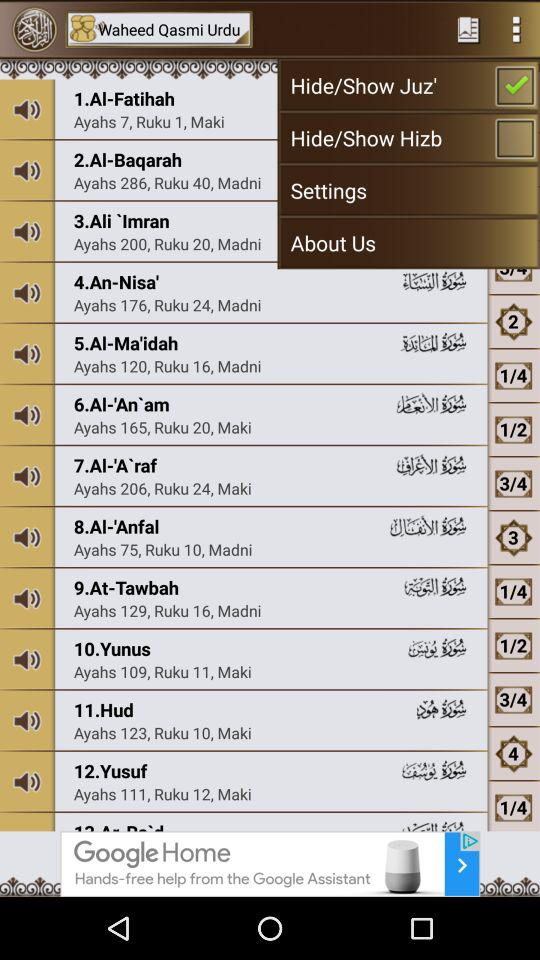How many rukus are there in "Yunus"? There are 11 rukus in "Yunus". 